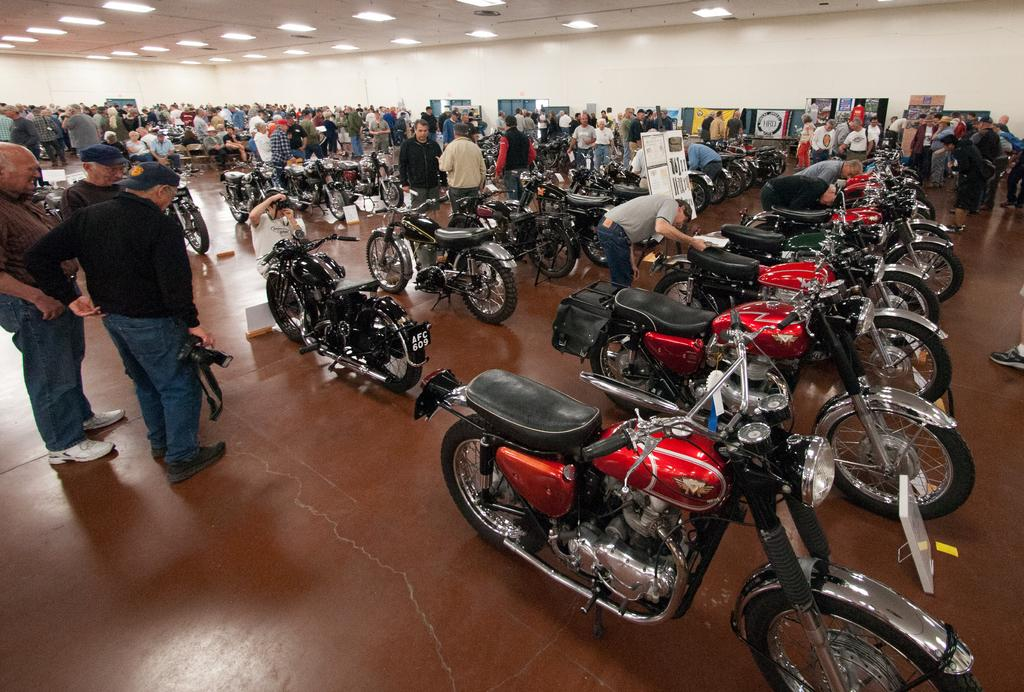What type of vehicles are in the image? There are bikes in the image. Can you describe the people in the image? There is a group of people in the image. What can be seen in the background of the image? There are hoardings and lights in the background of the image. What type of sweater is the writer wearing in the image? There is no writer or sweater present in the image. How many corks are visible in the image? There are no corks visible in the image. 